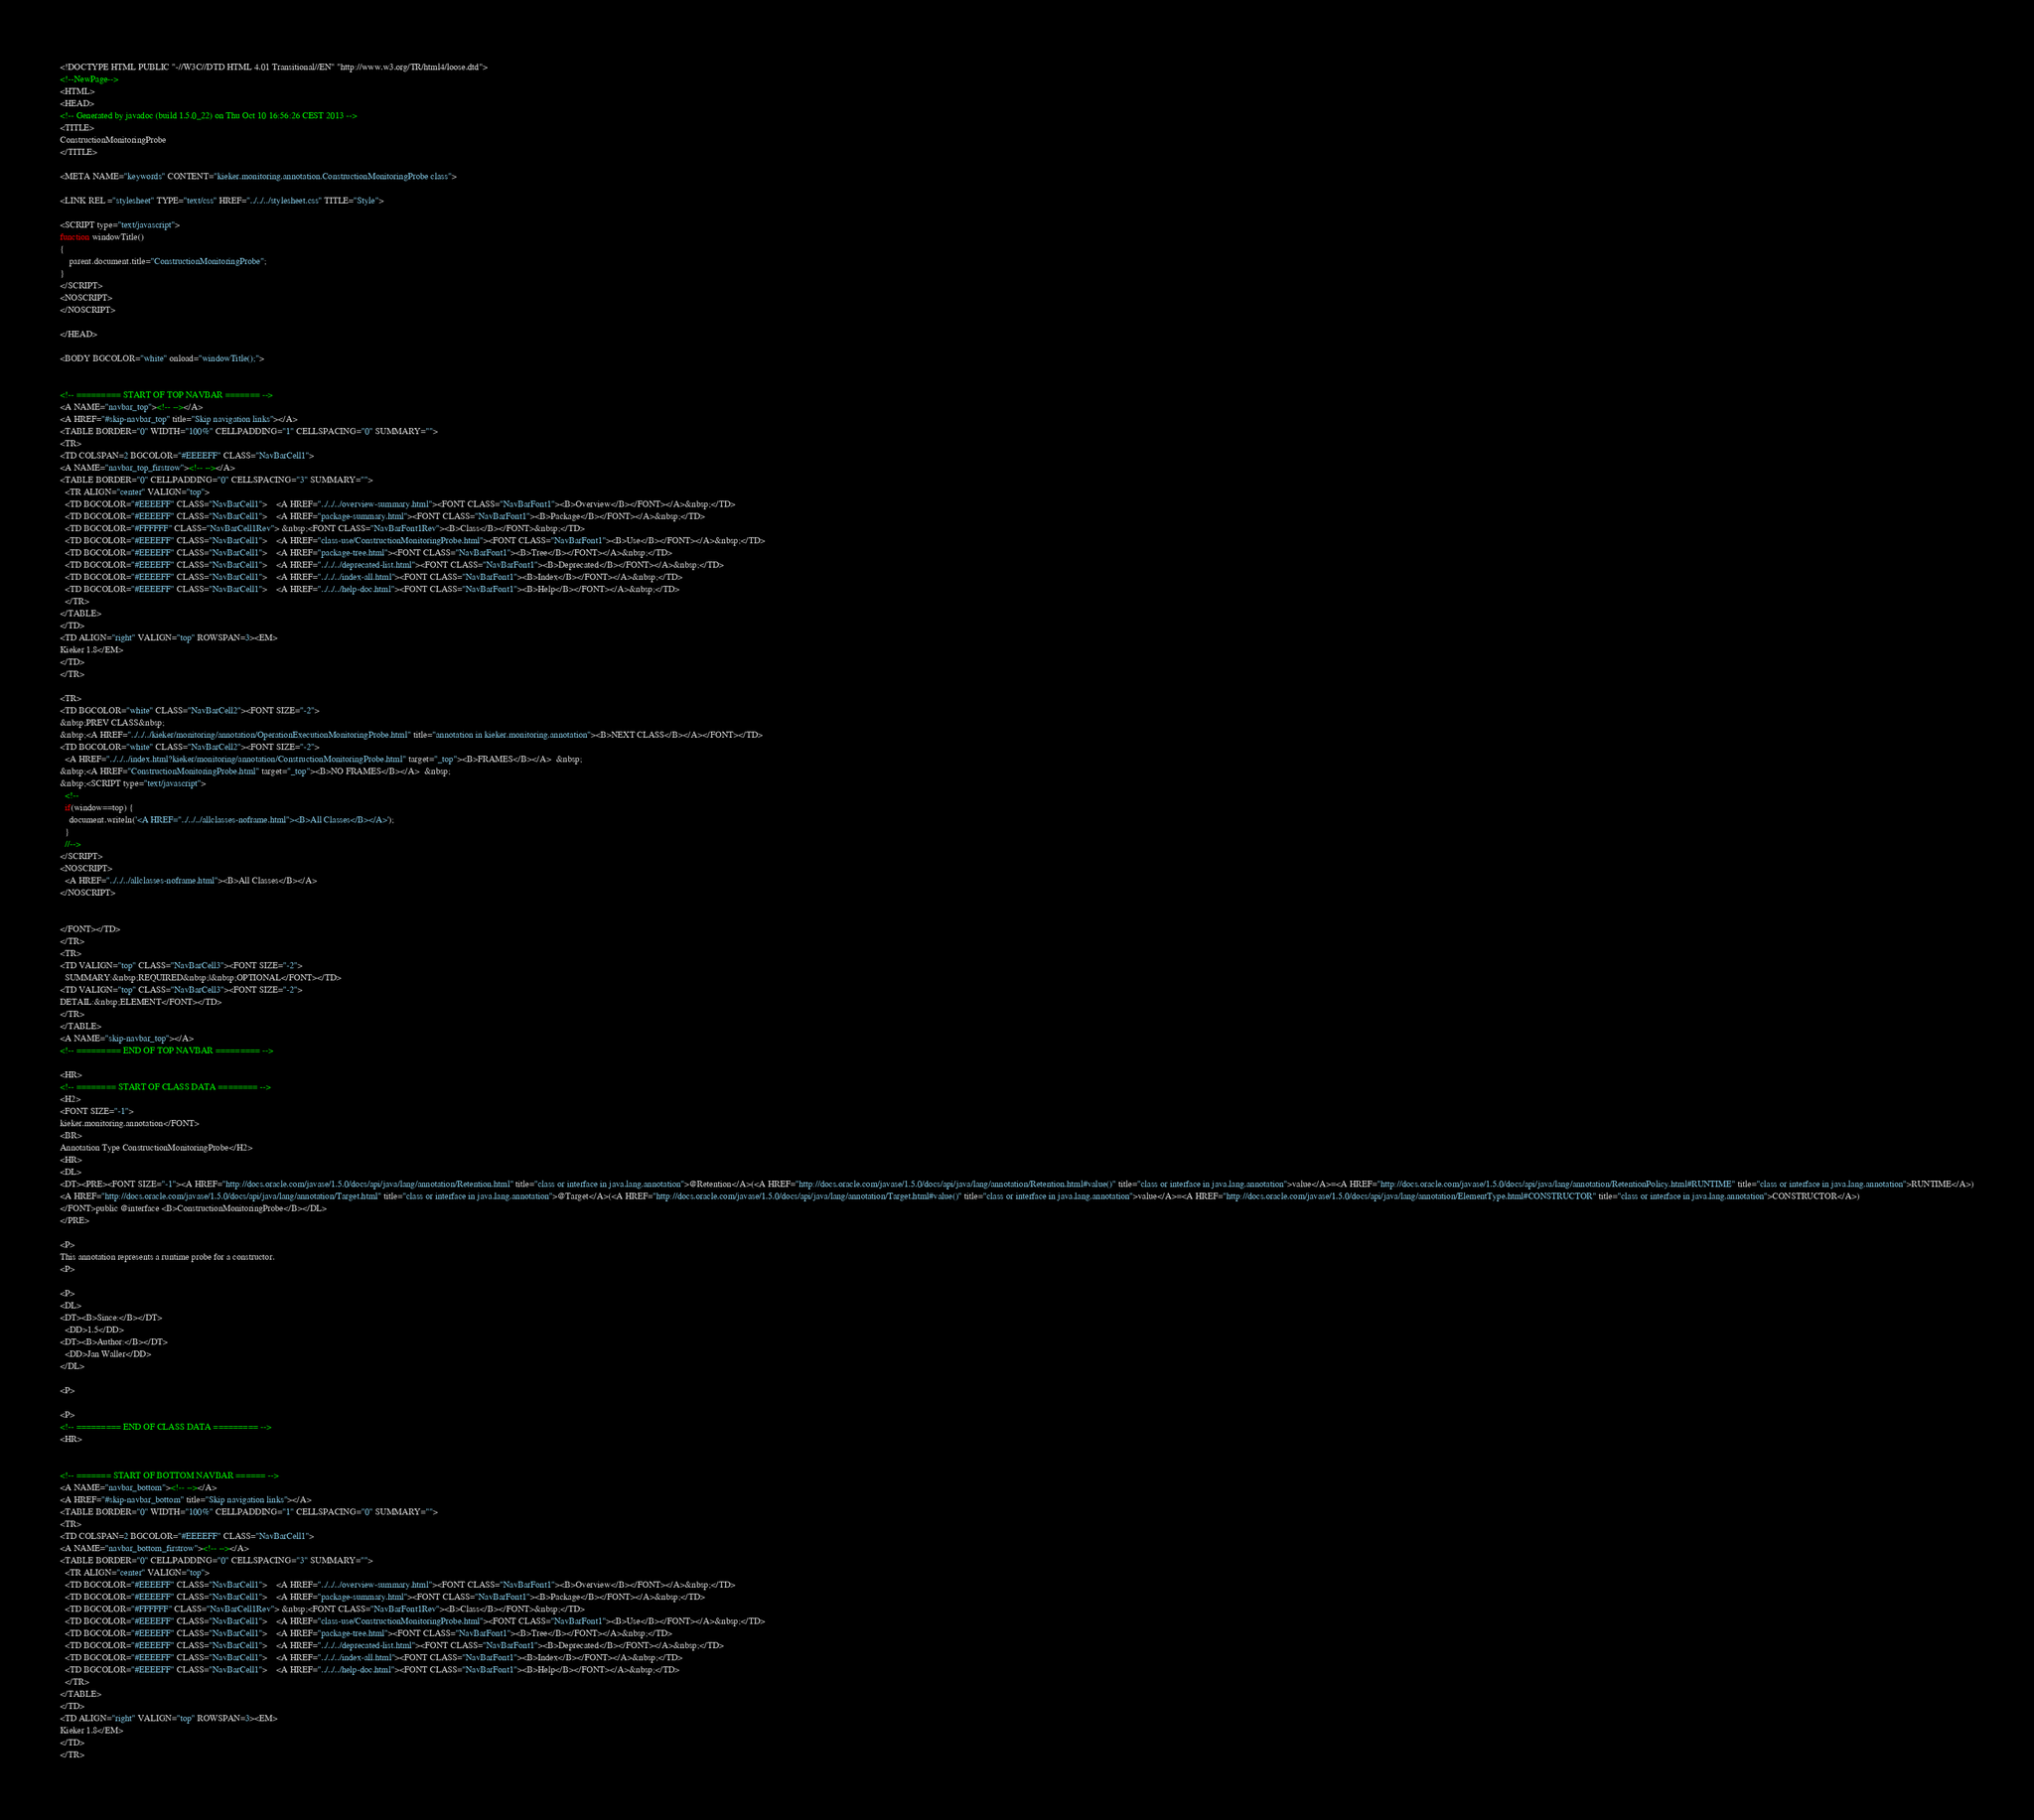<code> <loc_0><loc_0><loc_500><loc_500><_HTML_><!DOCTYPE HTML PUBLIC "-//W3C//DTD HTML 4.01 Transitional//EN" "http://www.w3.org/TR/html4/loose.dtd">
<!--NewPage-->
<HTML>
<HEAD>
<!-- Generated by javadoc (build 1.5.0_22) on Thu Oct 10 16:56:26 CEST 2013 -->
<TITLE>
ConstructionMonitoringProbe
</TITLE>

<META NAME="keywords" CONTENT="kieker.monitoring.annotation.ConstructionMonitoringProbe class">

<LINK REL ="stylesheet" TYPE="text/css" HREF="../../../stylesheet.css" TITLE="Style">

<SCRIPT type="text/javascript">
function windowTitle()
{
    parent.document.title="ConstructionMonitoringProbe";
}
</SCRIPT>
<NOSCRIPT>
</NOSCRIPT>

</HEAD>

<BODY BGCOLOR="white" onload="windowTitle();">


<!-- ========= START OF TOP NAVBAR ======= -->
<A NAME="navbar_top"><!-- --></A>
<A HREF="#skip-navbar_top" title="Skip navigation links"></A>
<TABLE BORDER="0" WIDTH="100%" CELLPADDING="1" CELLSPACING="0" SUMMARY="">
<TR>
<TD COLSPAN=2 BGCOLOR="#EEEEFF" CLASS="NavBarCell1">
<A NAME="navbar_top_firstrow"><!-- --></A>
<TABLE BORDER="0" CELLPADDING="0" CELLSPACING="3" SUMMARY="">
  <TR ALIGN="center" VALIGN="top">
  <TD BGCOLOR="#EEEEFF" CLASS="NavBarCell1">    <A HREF="../../../overview-summary.html"><FONT CLASS="NavBarFont1"><B>Overview</B></FONT></A>&nbsp;</TD>
  <TD BGCOLOR="#EEEEFF" CLASS="NavBarCell1">    <A HREF="package-summary.html"><FONT CLASS="NavBarFont1"><B>Package</B></FONT></A>&nbsp;</TD>
  <TD BGCOLOR="#FFFFFF" CLASS="NavBarCell1Rev"> &nbsp;<FONT CLASS="NavBarFont1Rev"><B>Class</B></FONT>&nbsp;</TD>
  <TD BGCOLOR="#EEEEFF" CLASS="NavBarCell1">    <A HREF="class-use/ConstructionMonitoringProbe.html"><FONT CLASS="NavBarFont1"><B>Use</B></FONT></A>&nbsp;</TD>
  <TD BGCOLOR="#EEEEFF" CLASS="NavBarCell1">    <A HREF="package-tree.html"><FONT CLASS="NavBarFont1"><B>Tree</B></FONT></A>&nbsp;</TD>
  <TD BGCOLOR="#EEEEFF" CLASS="NavBarCell1">    <A HREF="../../../deprecated-list.html"><FONT CLASS="NavBarFont1"><B>Deprecated</B></FONT></A>&nbsp;</TD>
  <TD BGCOLOR="#EEEEFF" CLASS="NavBarCell1">    <A HREF="../../../index-all.html"><FONT CLASS="NavBarFont1"><B>Index</B></FONT></A>&nbsp;</TD>
  <TD BGCOLOR="#EEEEFF" CLASS="NavBarCell1">    <A HREF="../../../help-doc.html"><FONT CLASS="NavBarFont1"><B>Help</B></FONT></A>&nbsp;</TD>
  </TR>
</TABLE>
</TD>
<TD ALIGN="right" VALIGN="top" ROWSPAN=3><EM>
Kieker 1.8</EM>
</TD>
</TR>

<TR>
<TD BGCOLOR="white" CLASS="NavBarCell2"><FONT SIZE="-2">
&nbsp;PREV CLASS&nbsp;
&nbsp;<A HREF="../../../kieker/monitoring/annotation/OperationExecutionMonitoringProbe.html" title="annotation in kieker.monitoring.annotation"><B>NEXT CLASS</B></A></FONT></TD>
<TD BGCOLOR="white" CLASS="NavBarCell2"><FONT SIZE="-2">
  <A HREF="../../../index.html?kieker/monitoring/annotation/ConstructionMonitoringProbe.html" target="_top"><B>FRAMES</B></A>  &nbsp;
&nbsp;<A HREF="ConstructionMonitoringProbe.html" target="_top"><B>NO FRAMES</B></A>  &nbsp;
&nbsp;<SCRIPT type="text/javascript">
  <!--
  if(window==top) {
    document.writeln('<A HREF="../../../allclasses-noframe.html"><B>All Classes</B></A>');
  }
  //-->
</SCRIPT>
<NOSCRIPT>
  <A HREF="../../../allclasses-noframe.html"><B>All Classes</B></A>
</NOSCRIPT>


</FONT></TD>
</TR>
<TR>
<TD VALIGN="top" CLASS="NavBarCell3"><FONT SIZE="-2">
  SUMMARY:&nbsp;REQUIRED&nbsp;|&nbsp;OPTIONAL</FONT></TD>
<TD VALIGN="top" CLASS="NavBarCell3"><FONT SIZE="-2">
DETAIL:&nbsp;ELEMENT</FONT></TD>
</TR>
</TABLE>
<A NAME="skip-navbar_top"></A>
<!-- ========= END OF TOP NAVBAR ========= -->

<HR>
<!-- ======== START OF CLASS DATA ======== -->
<H2>
<FONT SIZE="-1">
kieker.monitoring.annotation</FONT>
<BR>
Annotation Type ConstructionMonitoringProbe</H2>
<HR>
<DL>
<DT><PRE><FONT SIZE="-1"><A HREF="http://docs.oracle.com/javase/1.5.0/docs/api/java/lang/annotation/Retention.html" title="class or interface in java.lang.annotation">@Retention</A>(<A HREF="http://docs.oracle.com/javase/1.5.0/docs/api/java/lang/annotation/Retention.html#value()" title="class or interface in java.lang.annotation">value</A>=<A HREF="http://docs.oracle.com/javase/1.5.0/docs/api/java/lang/annotation/RetentionPolicy.html#RUNTIME" title="class or interface in java.lang.annotation">RUNTIME</A>)
<A HREF="http://docs.oracle.com/javase/1.5.0/docs/api/java/lang/annotation/Target.html" title="class or interface in java.lang.annotation">@Target</A>(<A HREF="http://docs.oracle.com/javase/1.5.0/docs/api/java/lang/annotation/Target.html#value()" title="class or interface in java.lang.annotation">value</A>=<A HREF="http://docs.oracle.com/javase/1.5.0/docs/api/java/lang/annotation/ElementType.html#CONSTRUCTOR" title="class or interface in java.lang.annotation">CONSTRUCTOR</A>)
</FONT>public @interface <B>ConstructionMonitoringProbe</B></DL>
</PRE>

<P>
This annotation represents a runtime probe for a constructor.
<P>

<P>
<DL>
<DT><B>Since:</B></DT>
  <DD>1.5</DD>
<DT><B>Author:</B></DT>
  <DD>Jan Waller</DD>
</DL>

<P>

<P>
<!-- ========= END OF CLASS DATA ========= -->
<HR>


<!-- ======= START OF BOTTOM NAVBAR ====== -->
<A NAME="navbar_bottom"><!-- --></A>
<A HREF="#skip-navbar_bottom" title="Skip navigation links"></A>
<TABLE BORDER="0" WIDTH="100%" CELLPADDING="1" CELLSPACING="0" SUMMARY="">
<TR>
<TD COLSPAN=2 BGCOLOR="#EEEEFF" CLASS="NavBarCell1">
<A NAME="navbar_bottom_firstrow"><!-- --></A>
<TABLE BORDER="0" CELLPADDING="0" CELLSPACING="3" SUMMARY="">
  <TR ALIGN="center" VALIGN="top">
  <TD BGCOLOR="#EEEEFF" CLASS="NavBarCell1">    <A HREF="../../../overview-summary.html"><FONT CLASS="NavBarFont1"><B>Overview</B></FONT></A>&nbsp;</TD>
  <TD BGCOLOR="#EEEEFF" CLASS="NavBarCell1">    <A HREF="package-summary.html"><FONT CLASS="NavBarFont1"><B>Package</B></FONT></A>&nbsp;</TD>
  <TD BGCOLOR="#FFFFFF" CLASS="NavBarCell1Rev"> &nbsp;<FONT CLASS="NavBarFont1Rev"><B>Class</B></FONT>&nbsp;</TD>
  <TD BGCOLOR="#EEEEFF" CLASS="NavBarCell1">    <A HREF="class-use/ConstructionMonitoringProbe.html"><FONT CLASS="NavBarFont1"><B>Use</B></FONT></A>&nbsp;</TD>
  <TD BGCOLOR="#EEEEFF" CLASS="NavBarCell1">    <A HREF="package-tree.html"><FONT CLASS="NavBarFont1"><B>Tree</B></FONT></A>&nbsp;</TD>
  <TD BGCOLOR="#EEEEFF" CLASS="NavBarCell1">    <A HREF="../../../deprecated-list.html"><FONT CLASS="NavBarFont1"><B>Deprecated</B></FONT></A>&nbsp;</TD>
  <TD BGCOLOR="#EEEEFF" CLASS="NavBarCell1">    <A HREF="../../../index-all.html"><FONT CLASS="NavBarFont1"><B>Index</B></FONT></A>&nbsp;</TD>
  <TD BGCOLOR="#EEEEFF" CLASS="NavBarCell1">    <A HREF="../../../help-doc.html"><FONT CLASS="NavBarFont1"><B>Help</B></FONT></A>&nbsp;</TD>
  </TR>
</TABLE>
</TD>
<TD ALIGN="right" VALIGN="top" ROWSPAN=3><EM>
Kieker 1.8</EM>
</TD>
</TR>
</code> 